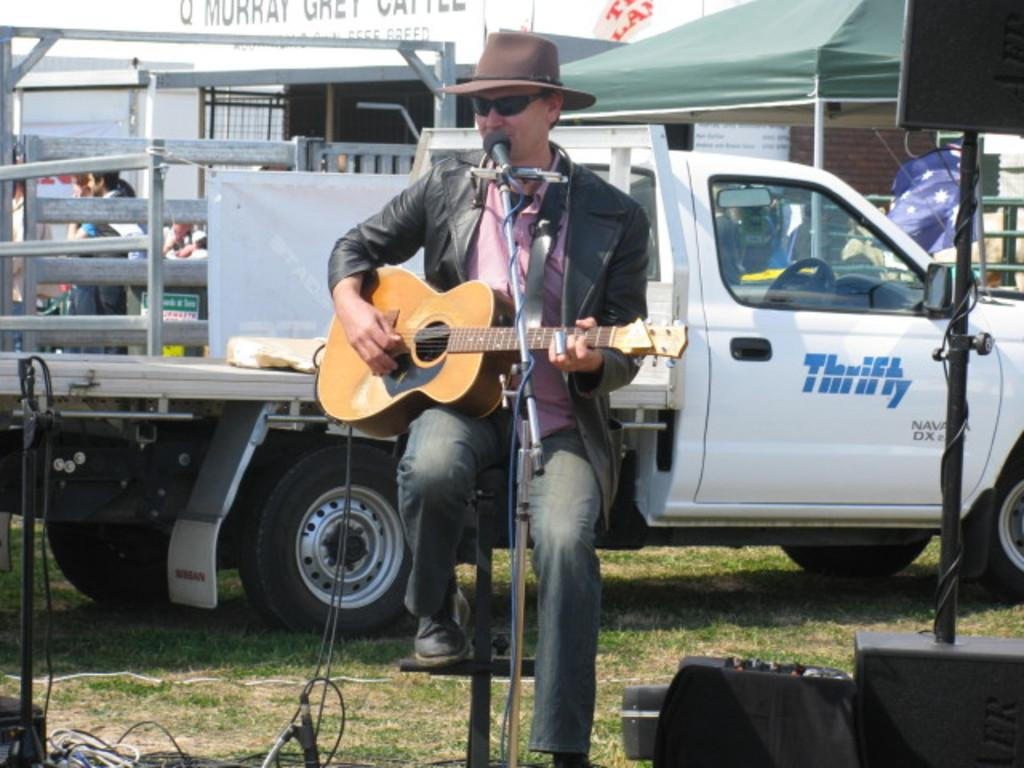What is the person in the image doing? The person is sitting and holding a guitar. What object is in front of the person? There is a microphone in front of the person. What can be seen in the background of the image? There are vehicles and people standing in the background of the image. What type of needle is being used to create the rhythm in the image? There is no needle or rhythm present in the image; it features a person holding a guitar and a microphone. 